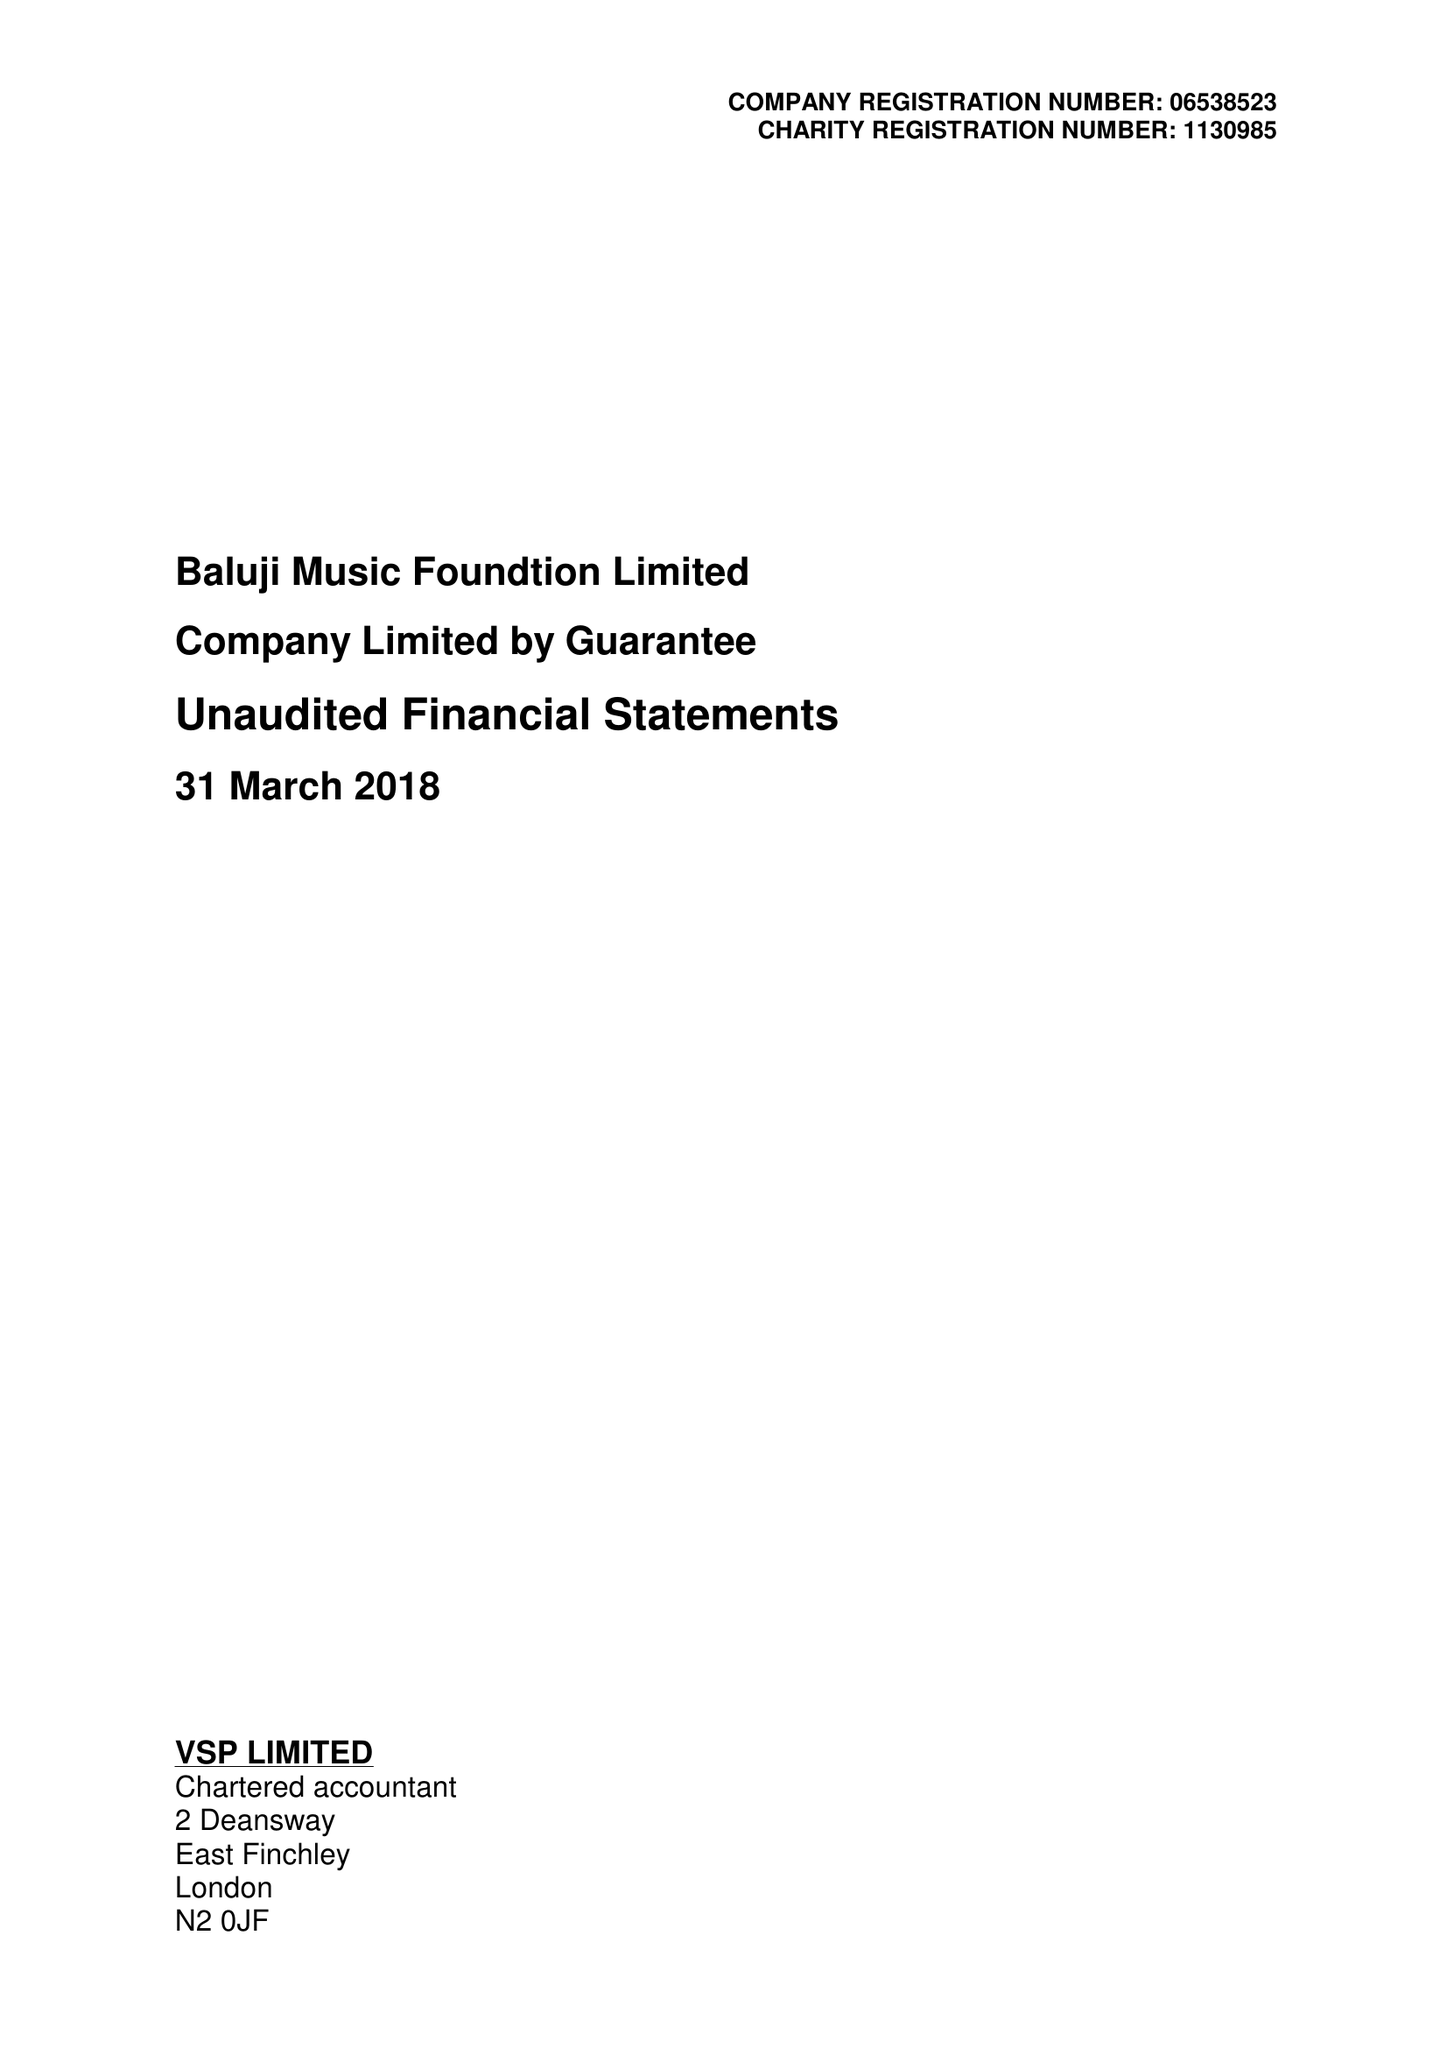What is the value for the charity_number?
Answer the question using a single word or phrase. 1130985 